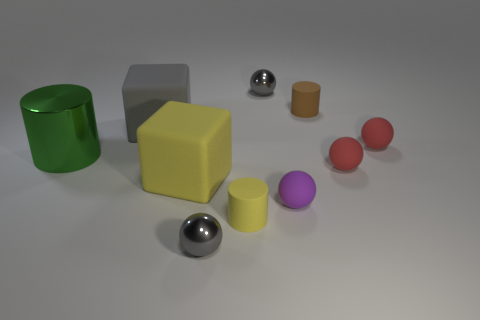Beside the primary shapes, are there any other interesting details to note in this scene? Aside from the primary geometric shapes, the scene is relatively simple. However, the lighting creates a subtle interplay of shadows and reflections on the surfaces, adding depth to the otherwise static arrangement. 